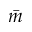Convert formula to latex. <formula><loc_0><loc_0><loc_500><loc_500>\bar { m }</formula> 